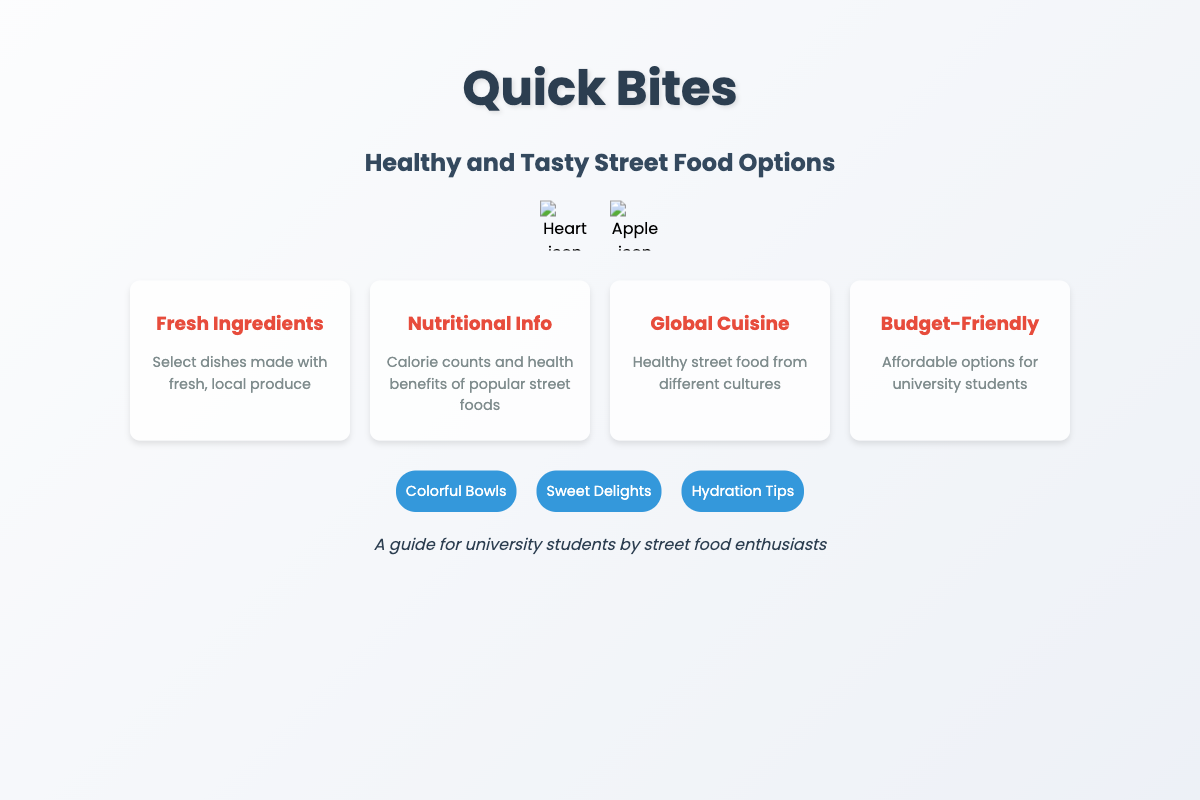What is the title of the book? The title is prominently displayed at the top of the document, which is "Quick Bites."
Answer: Quick Bites What are the primary themes of the book? The main theme of the book is highlighted in the subtitle, describing it as a guide for healthy and tasty street food options.
Answer: Healthy and Tasty Street Food Options Who is the target audience of the book? The target audience is indicated in the author section, which mentions "A guide for university students."
Answer: University students What type of food options does the book promote? The features listed suggest that the book promotes nutritious and affordable food choices, specifically from street food vendors.
Answer: Nutritious and affordable What icon is associated with health in the document? The health icon presented in the icons section represents a healthy lifestyle and is a heart symbol.
Answer: Heart icon How many features are presented on the book cover? The features section displays four distinct features related to street food options, which can be counted directly.
Answer: Four features Which feature mentions affordability? The last feature specifically addresses budget-friendly options for students, emphasizing the importance of being economical.
Answer: Budget-Friendly Name one highlight mentioned on the cover. The highlights section lists several features, of which "Colorful Bowls" is one example.
Answer: Colorful Bowls What background image is used on the cover? The background is described through the CSS as a colorful street food vendor image, which represents the main theme of the book.
Answer: Colorful street food vendor 